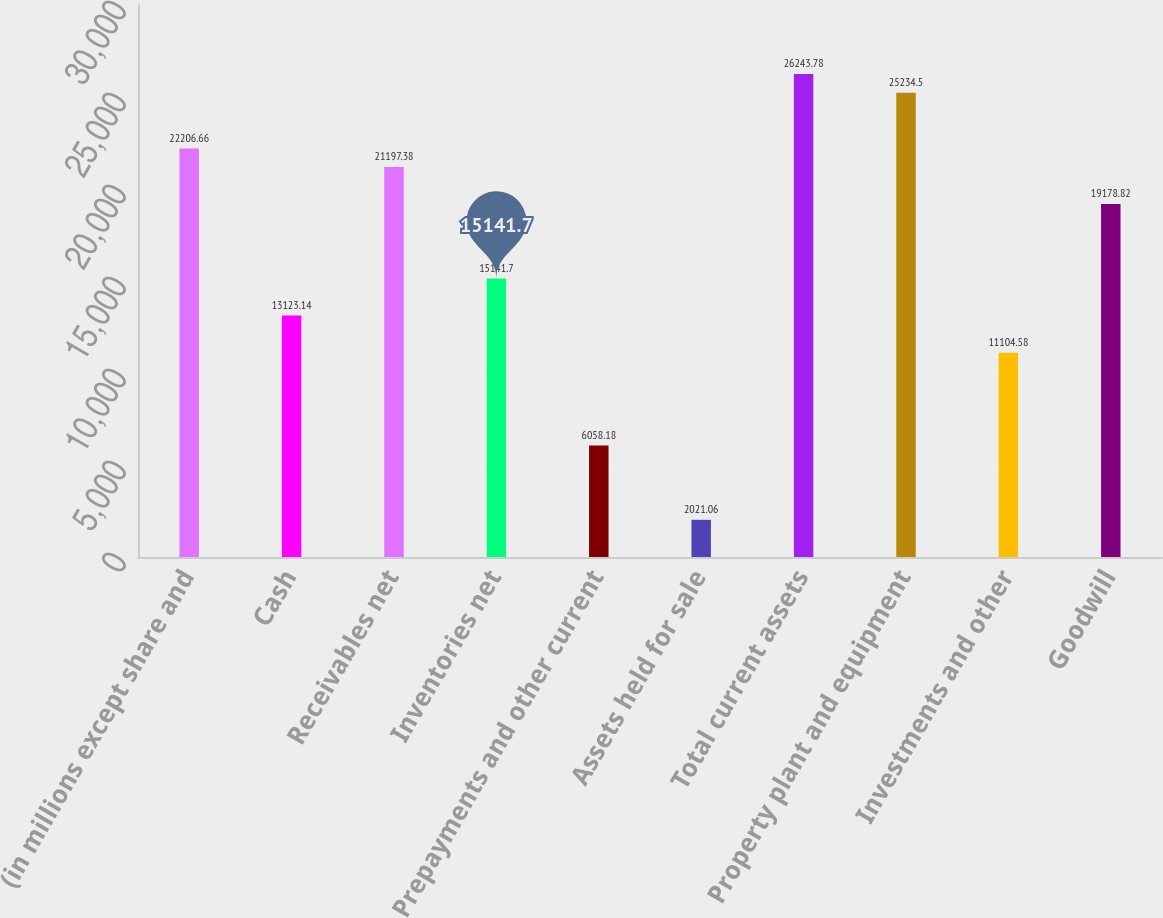Convert chart to OTSL. <chart><loc_0><loc_0><loc_500><loc_500><bar_chart><fcel>(in millions except share and<fcel>Cash<fcel>Receivables net<fcel>Inventories net<fcel>Prepayments and other current<fcel>Assets held for sale<fcel>Total current assets<fcel>Property plant and equipment<fcel>Investments and other<fcel>Goodwill<nl><fcel>22206.7<fcel>13123.1<fcel>21197.4<fcel>15141.7<fcel>6058.18<fcel>2021.06<fcel>26243.8<fcel>25234.5<fcel>11104.6<fcel>19178.8<nl></chart> 